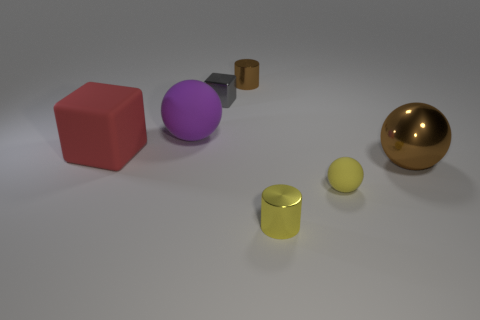Can you describe the shapes and materials of the objects starting from the left? Sure, starting from the left, there is a red cube that appears to be made of a matte material, possibly plastic. Next is a purple sphere with a smooth, shiny texture, akin to polished metal or plastic. Then there is the small, gray metallic cylinder, followed by a mid-sized brown box with a matte, wooden appearance. In front, we see a yellow cylinder with a glossy finish that could be metal or plastic, and further right, there's a small yellow sphere, matching the cylinder in color and sheen. 